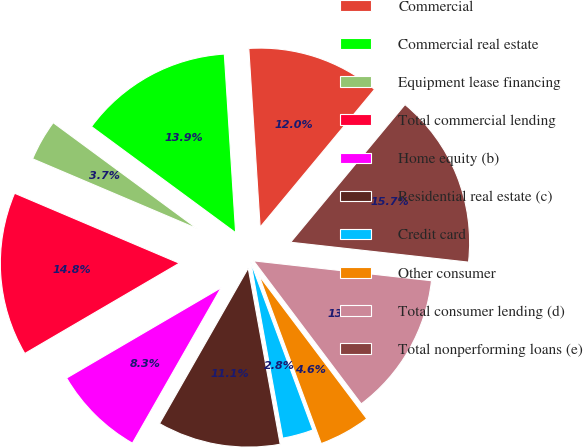Convert chart. <chart><loc_0><loc_0><loc_500><loc_500><pie_chart><fcel>Commercial<fcel>Commercial real estate<fcel>Equipment lease financing<fcel>Total commercial lending<fcel>Home equity (b)<fcel>Residential real estate (c)<fcel>Credit card<fcel>Other consumer<fcel>Total consumer lending (d)<fcel>Total nonperforming loans (e)<nl><fcel>12.04%<fcel>13.89%<fcel>3.71%<fcel>14.81%<fcel>8.33%<fcel>11.11%<fcel>2.78%<fcel>4.63%<fcel>12.96%<fcel>15.74%<nl></chart> 